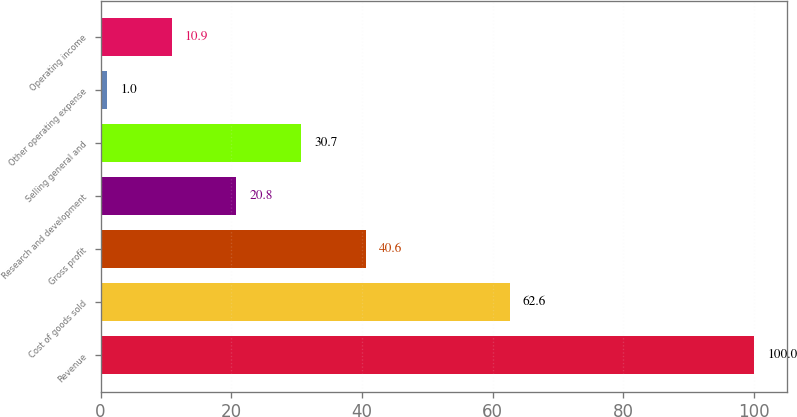<chart> <loc_0><loc_0><loc_500><loc_500><bar_chart><fcel>Revenue<fcel>Cost of goods sold<fcel>Gross profit<fcel>Research and development<fcel>Selling general and<fcel>Other operating expense<fcel>Operating income<nl><fcel>100<fcel>62.6<fcel>40.6<fcel>20.8<fcel>30.7<fcel>1<fcel>10.9<nl></chart> 